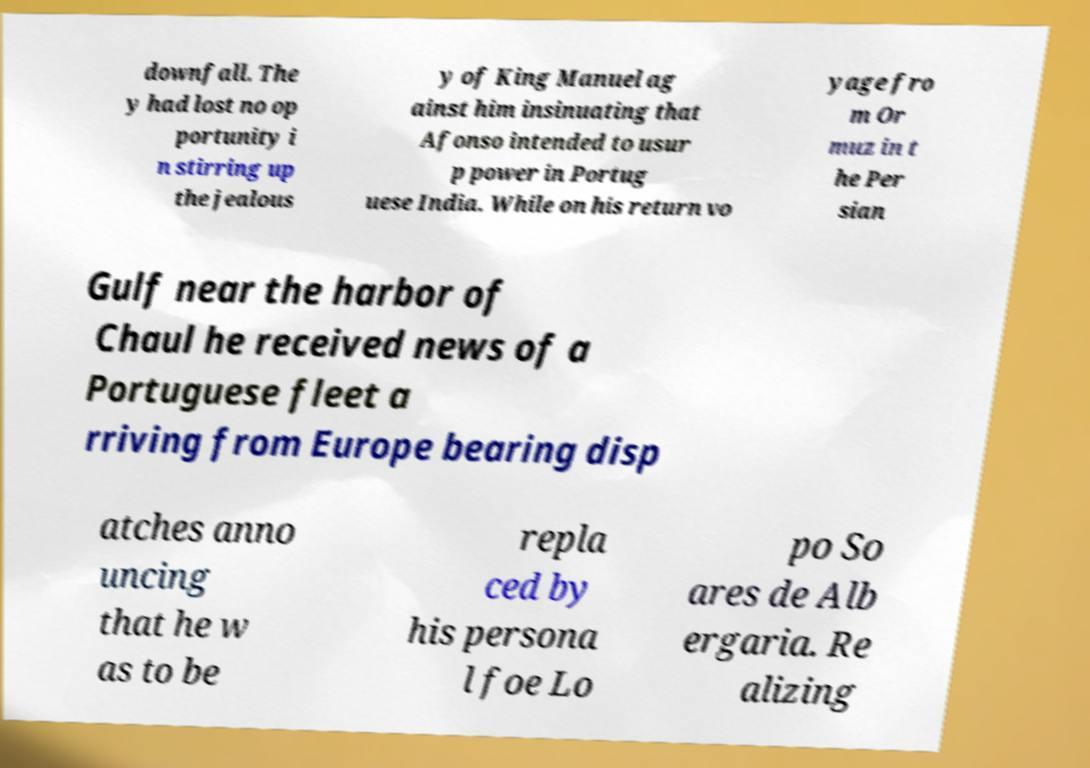Could you extract and type out the text from this image? downfall. The y had lost no op portunity i n stirring up the jealous y of King Manuel ag ainst him insinuating that Afonso intended to usur p power in Portug uese India. While on his return vo yage fro m Or muz in t he Per sian Gulf near the harbor of Chaul he received news of a Portuguese fleet a rriving from Europe bearing disp atches anno uncing that he w as to be repla ced by his persona l foe Lo po So ares de Alb ergaria. Re alizing 